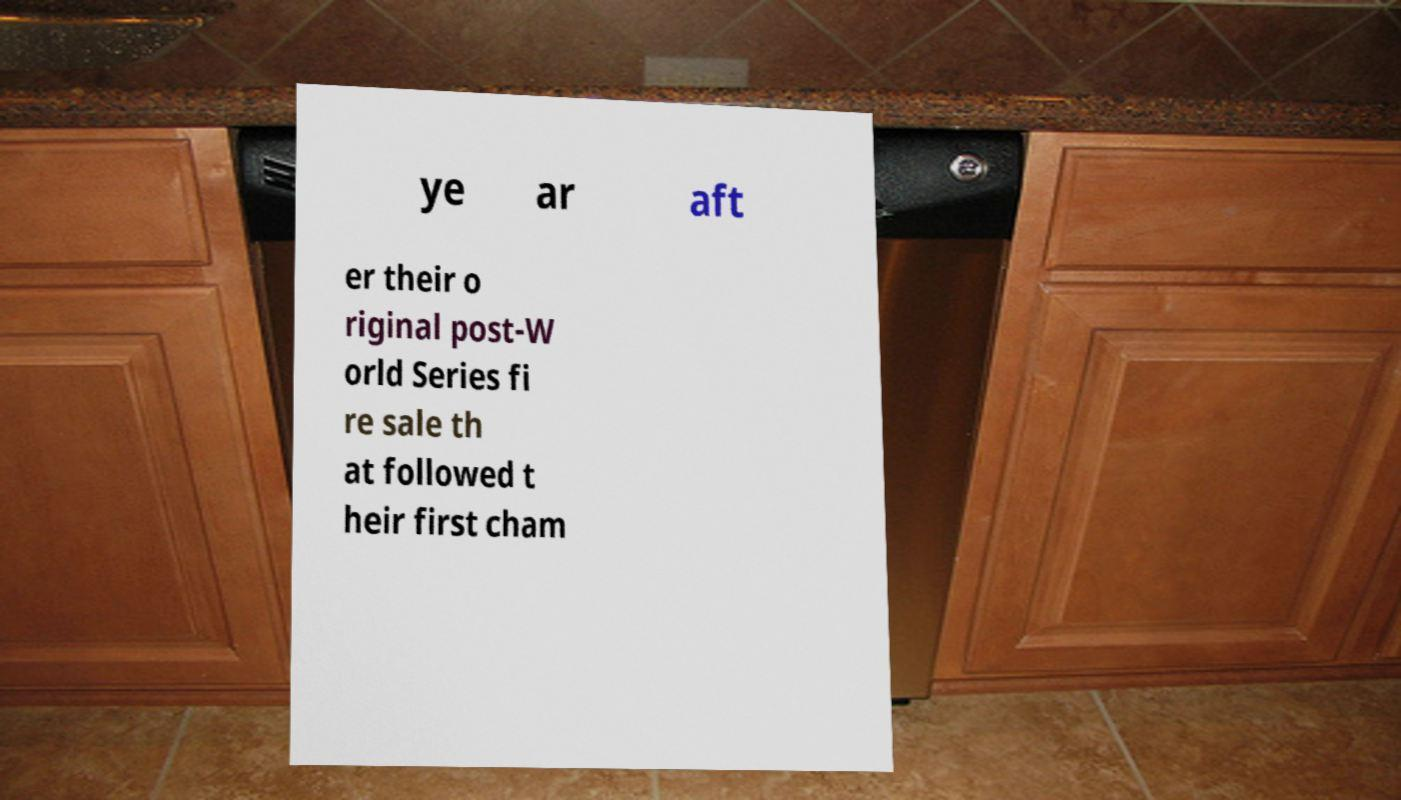For documentation purposes, I need the text within this image transcribed. Could you provide that? ye ar aft er their o riginal post-W orld Series fi re sale th at followed t heir first cham 